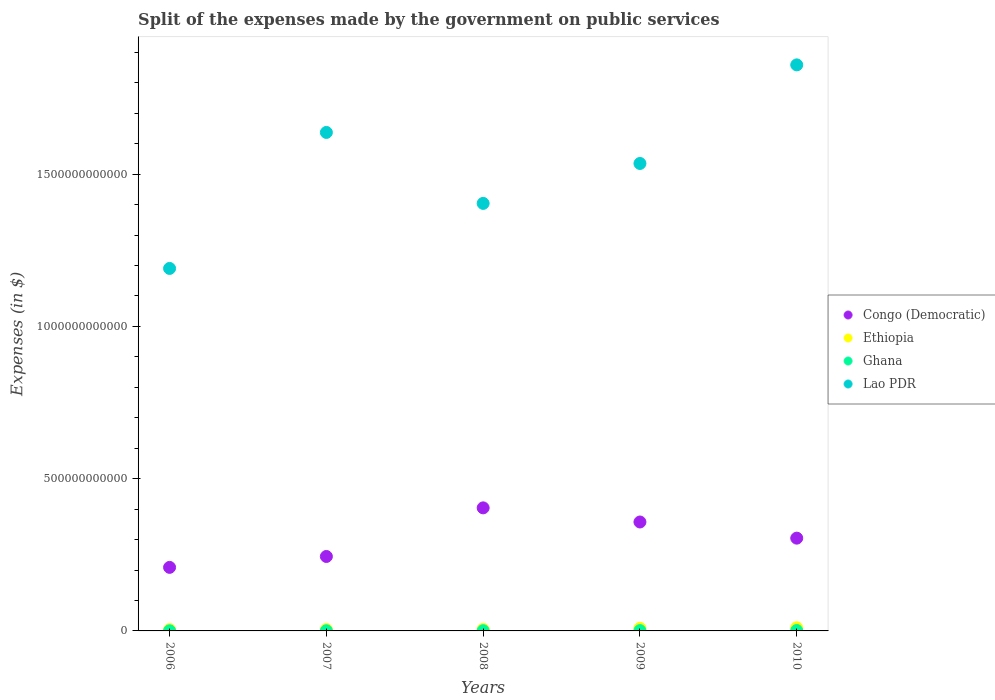Is the number of dotlines equal to the number of legend labels?
Give a very brief answer. Yes. What is the expenses made by the government on public services in Congo (Democratic) in 2007?
Your answer should be compact. 2.44e+11. Across all years, what is the maximum expenses made by the government on public services in Lao PDR?
Provide a succinct answer. 1.86e+12. Across all years, what is the minimum expenses made by the government on public services in Congo (Democratic)?
Offer a very short reply. 2.09e+11. In which year was the expenses made by the government on public services in Congo (Democratic) minimum?
Ensure brevity in your answer.  2006. What is the total expenses made by the government on public services in Ghana in the graph?
Offer a very short reply. 4.28e+09. What is the difference between the expenses made by the government on public services in Lao PDR in 2006 and that in 2009?
Make the answer very short. -3.45e+11. What is the difference between the expenses made by the government on public services in Ghana in 2008 and the expenses made by the government on public services in Congo (Democratic) in 2010?
Provide a succinct answer. -3.04e+11. What is the average expenses made by the government on public services in Ghana per year?
Provide a succinct answer. 8.55e+08. In the year 2008, what is the difference between the expenses made by the government on public services in Congo (Democratic) and expenses made by the government on public services in Ethiopia?
Offer a terse response. 3.99e+11. In how many years, is the expenses made by the government on public services in Lao PDR greater than 900000000000 $?
Provide a short and direct response. 5. What is the ratio of the expenses made by the government on public services in Congo (Democratic) in 2006 to that in 2008?
Provide a succinct answer. 0.52. Is the expenses made by the government on public services in Congo (Democratic) in 2006 less than that in 2007?
Your response must be concise. Yes. Is the difference between the expenses made by the government on public services in Congo (Democratic) in 2009 and 2010 greater than the difference between the expenses made by the government on public services in Ethiopia in 2009 and 2010?
Give a very brief answer. Yes. What is the difference between the highest and the second highest expenses made by the government on public services in Congo (Democratic)?
Give a very brief answer. 4.64e+1. What is the difference between the highest and the lowest expenses made by the government on public services in Congo (Democratic)?
Your answer should be very brief. 1.95e+11. Is the sum of the expenses made by the government on public services in Congo (Democratic) in 2007 and 2009 greater than the maximum expenses made by the government on public services in Ghana across all years?
Your response must be concise. Yes. Is it the case that in every year, the sum of the expenses made by the government on public services in Ethiopia and expenses made by the government on public services in Ghana  is greater than the sum of expenses made by the government on public services in Congo (Democratic) and expenses made by the government on public services in Lao PDR?
Your answer should be compact. No. Is it the case that in every year, the sum of the expenses made by the government on public services in Lao PDR and expenses made by the government on public services in Congo (Democratic)  is greater than the expenses made by the government on public services in Ethiopia?
Make the answer very short. Yes. Is the expenses made by the government on public services in Ethiopia strictly less than the expenses made by the government on public services in Lao PDR over the years?
Offer a very short reply. Yes. What is the difference between two consecutive major ticks on the Y-axis?
Give a very brief answer. 5.00e+11. Does the graph contain any zero values?
Ensure brevity in your answer.  No. How are the legend labels stacked?
Your answer should be very brief. Vertical. What is the title of the graph?
Ensure brevity in your answer.  Split of the expenses made by the government on public services. Does "Turks and Caicos Islands" appear as one of the legend labels in the graph?
Your answer should be compact. No. What is the label or title of the X-axis?
Offer a terse response. Years. What is the label or title of the Y-axis?
Your answer should be very brief. Expenses (in $). What is the Expenses (in $) in Congo (Democratic) in 2006?
Give a very brief answer. 2.09e+11. What is the Expenses (in $) of Ethiopia in 2006?
Offer a very short reply. 4.31e+09. What is the Expenses (in $) of Ghana in 2006?
Provide a short and direct response. 4.57e+08. What is the Expenses (in $) in Lao PDR in 2006?
Ensure brevity in your answer.  1.19e+12. What is the Expenses (in $) in Congo (Democratic) in 2007?
Your response must be concise. 2.44e+11. What is the Expenses (in $) in Ethiopia in 2007?
Your response must be concise. 4.71e+09. What is the Expenses (in $) in Ghana in 2007?
Offer a terse response. 6.16e+08. What is the Expenses (in $) in Lao PDR in 2007?
Provide a short and direct response. 1.64e+12. What is the Expenses (in $) in Congo (Democratic) in 2008?
Provide a short and direct response. 4.04e+11. What is the Expenses (in $) of Ethiopia in 2008?
Your answer should be very brief. 5.04e+09. What is the Expenses (in $) of Ghana in 2008?
Offer a very short reply. 7.44e+08. What is the Expenses (in $) in Lao PDR in 2008?
Your response must be concise. 1.40e+12. What is the Expenses (in $) of Congo (Democratic) in 2009?
Your answer should be very brief. 3.58e+11. What is the Expenses (in $) of Ethiopia in 2009?
Offer a very short reply. 8.59e+09. What is the Expenses (in $) of Ghana in 2009?
Provide a succinct answer. 1.09e+09. What is the Expenses (in $) of Lao PDR in 2009?
Your answer should be compact. 1.54e+12. What is the Expenses (in $) in Congo (Democratic) in 2010?
Make the answer very short. 3.05e+11. What is the Expenses (in $) in Ethiopia in 2010?
Your answer should be very brief. 1.04e+1. What is the Expenses (in $) of Ghana in 2010?
Ensure brevity in your answer.  1.37e+09. What is the Expenses (in $) in Lao PDR in 2010?
Offer a very short reply. 1.86e+12. Across all years, what is the maximum Expenses (in $) of Congo (Democratic)?
Provide a short and direct response. 4.04e+11. Across all years, what is the maximum Expenses (in $) in Ethiopia?
Ensure brevity in your answer.  1.04e+1. Across all years, what is the maximum Expenses (in $) of Ghana?
Ensure brevity in your answer.  1.37e+09. Across all years, what is the maximum Expenses (in $) in Lao PDR?
Keep it short and to the point. 1.86e+12. Across all years, what is the minimum Expenses (in $) in Congo (Democratic)?
Offer a terse response. 2.09e+11. Across all years, what is the minimum Expenses (in $) in Ethiopia?
Your response must be concise. 4.31e+09. Across all years, what is the minimum Expenses (in $) in Ghana?
Provide a short and direct response. 4.57e+08. Across all years, what is the minimum Expenses (in $) in Lao PDR?
Give a very brief answer. 1.19e+12. What is the total Expenses (in $) of Congo (Democratic) in the graph?
Ensure brevity in your answer.  1.52e+12. What is the total Expenses (in $) in Ethiopia in the graph?
Provide a succinct answer. 3.30e+1. What is the total Expenses (in $) of Ghana in the graph?
Provide a succinct answer. 4.28e+09. What is the total Expenses (in $) in Lao PDR in the graph?
Your answer should be very brief. 7.63e+12. What is the difference between the Expenses (in $) in Congo (Democratic) in 2006 and that in 2007?
Keep it short and to the point. -3.58e+1. What is the difference between the Expenses (in $) in Ethiopia in 2006 and that in 2007?
Your answer should be compact. -3.93e+08. What is the difference between the Expenses (in $) of Ghana in 2006 and that in 2007?
Provide a succinct answer. -1.59e+08. What is the difference between the Expenses (in $) of Lao PDR in 2006 and that in 2007?
Make the answer very short. -4.47e+11. What is the difference between the Expenses (in $) in Congo (Democratic) in 2006 and that in 2008?
Your answer should be very brief. -1.95e+11. What is the difference between the Expenses (in $) of Ethiopia in 2006 and that in 2008?
Make the answer very short. -7.27e+08. What is the difference between the Expenses (in $) of Ghana in 2006 and that in 2008?
Provide a short and direct response. -2.87e+08. What is the difference between the Expenses (in $) of Lao PDR in 2006 and that in 2008?
Offer a terse response. -2.14e+11. What is the difference between the Expenses (in $) of Congo (Democratic) in 2006 and that in 2009?
Keep it short and to the point. -1.49e+11. What is the difference between the Expenses (in $) of Ethiopia in 2006 and that in 2009?
Your response must be concise. -4.27e+09. What is the difference between the Expenses (in $) of Ghana in 2006 and that in 2009?
Make the answer very short. -6.30e+08. What is the difference between the Expenses (in $) of Lao PDR in 2006 and that in 2009?
Ensure brevity in your answer.  -3.45e+11. What is the difference between the Expenses (in $) in Congo (Democratic) in 2006 and that in 2010?
Offer a very short reply. -9.60e+1. What is the difference between the Expenses (in $) of Ethiopia in 2006 and that in 2010?
Provide a succinct answer. -6.05e+09. What is the difference between the Expenses (in $) of Ghana in 2006 and that in 2010?
Make the answer very short. -9.15e+08. What is the difference between the Expenses (in $) in Lao PDR in 2006 and that in 2010?
Your answer should be compact. -6.68e+11. What is the difference between the Expenses (in $) in Congo (Democratic) in 2007 and that in 2008?
Offer a terse response. -1.60e+11. What is the difference between the Expenses (in $) of Ethiopia in 2007 and that in 2008?
Your answer should be very brief. -3.34e+08. What is the difference between the Expenses (in $) of Ghana in 2007 and that in 2008?
Provide a succinct answer. -1.28e+08. What is the difference between the Expenses (in $) of Lao PDR in 2007 and that in 2008?
Provide a short and direct response. 2.33e+11. What is the difference between the Expenses (in $) in Congo (Democratic) in 2007 and that in 2009?
Offer a terse response. -1.13e+11. What is the difference between the Expenses (in $) in Ethiopia in 2007 and that in 2009?
Provide a succinct answer. -3.88e+09. What is the difference between the Expenses (in $) in Ghana in 2007 and that in 2009?
Keep it short and to the point. -4.72e+08. What is the difference between the Expenses (in $) in Lao PDR in 2007 and that in 2009?
Keep it short and to the point. 1.02e+11. What is the difference between the Expenses (in $) of Congo (Democratic) in 2007 and that in 2010?
Your answer should be compact. -6.02e+1. What is the difference between the Expenses (in $) of Ethiopia in 2007 and that in 2010?
Your response must be concise. -5.66e+09. What is the difference between the Expenses (in $) of Ghana in 2007 and that in 2010?
Make the answer very short. -7.56e+08. What is the difference between the Expenses (in $) of Lao PDR in 2007 and that in 2010?
Your answer should be very brief. -2.22e+11. What is the difference between the Expenses (in $) in Congo (Democratic) in 2008 and that in 2009?
Keep it short and to the point. 4.64e+1. What is the difference between the Expenses (in $) in Ethiopia in 2008 and that in 2009?
Keep it short and to the point. -3.55e+09. What is the difference between the Expenses (in $) in Ghana in 2008 and that in 2009?
Provide a succinct answer. -3.44e+08. What is the difference between the Expenses (in $) of Lao PDR in 2008 and that in 2009?
Provide a succinct answer. -1.31e+11. What is the difference between the Expenses (in $) of Congo (Democratic) in 2008 and that in 2010?
Make the answer very short. 9.95e+1. What is the difference between the Expenses (in $) of Ethiopia in 2008 and that in 2010?
Your answer should be very brief. -5.32e+09. What is the difference between the Expenses (in $) of Ghana in 2008 and that in 2010?
Provide a succinct answer. -6.28e+08. What is the difference between the Expenses (in $) in Lao PDR in 2008 and that in 2010?
Make the answer very short. -4.55e+11. What is the difference between the Expenses (in $) of Congo (Democratic) in 2009 and that in 2010?
Make the answer very short. 5.30e+1. What is the difference between the Expenses (in $) of Ethiopia in 2009 and that in 2010?
Offer a terse response. -1.78e+09. What is the difference between the Expenses (in $) of Ghana in 2009 and that in 2010?
Offer a terse response. -2.84e+08. What is the difference between the Expenses (in $) in Lao PDR in 2009 and that in 2010?
Your answer should be compact. -3.24e+11. What is the difference between the Expenses (in $) in Congo (Democratic) in 2006 and the Expenses (in $) in Ethiopia in 2007?
Keep it short and to the point. 2.04e+11. What is the difference between the Expenses (in $) in Congo (Democratic) in 2006 and the Expenses (in $) in Ghana in 2007?
Your answer should be compact. 2.08e+11. What is the difference between the Expenses (in $) of Congo (Democratic) in 2006 and the Expenses (in $) of Lao PDR in 2007?
Offer a terse response. -1.43e+12. What is the difference between the Expenses (in $) of Ethiopia in 2006 and the Expenses (in $) of Ghana in 2007?
Your answer should be very brief. 3.70e+09. What is the difference between the Expenses (in $) of Ethiopia in 2006 and the Expenses (in $) of Lao PDR in 2007?
Ensure brevity in your answer.  -1.63e+12. What is the difference between the Expenses (in $) in Ghana in 2006 and the Expenses (in $) in Lao PDR in 2007?
Keep it short and to the point. -1.64e+12. What is the difference between the Expenses (in $) of Congo (Democratic) in 2006 and the Expenses (in $) of Ethiopia in 2008?
Your answer should be compact. 2.04e+11. What is the difference between the Expenses (in $) of Congo (Democratic) in 2006 and the Expenses (in $) of Ghana in 2008?
Keep it short and to the point. 2.08e+11. What is the difference between the Expenses (in $) in Congo (Democratic) in 2006 and the Expenses (in $) in Lao PDR in 2008?
Your response must be concise. -1.20e+12. What is the difference between the Expenses (in $) in Ethiopia in 2006 and the Expenses (in $) in Ghana in 2008?
Keep it short and to the point. 3.57e+09. What is the difference between the Expenses (in $) of Ethiopia in 2006 and the Expenses (in $) of Lao PDR in 2008?
Your answer should be compact. -1.40e+12. What is the difference between the Expenses (in $) in Ghana in 2006 and the Expenses (in $) in Lao PDR in 2008?
Provide a short and direct response. -1.40e+12. What is the difference between the Expenses (in $) of Congo (Democratic) in 2006 and the Expenses (in $) of Ethiopia in 2009?
Your answer should be very brief. 2.00e+11. What is the difference between the Expenses (in $) in Congo (Democratic) in 2006 and the Expenses (in $) in Ghana in 2009?
Ensure brevity in your answer.  2.08e+11. What is the difference between the Expenses (in $) of Congo (Democratic) in 2006 and the Expenses (in $) of Lao PDR in 2009?
Your response must be concise. -1.33e+12. What is the difference between the Expenses (in $) in Ethiopia in 2006 and the Expenses (in $) in Ghana in 2009?
Offer a terse response. 3.23e+09. What is the difference between the Expenses (in $) of Ethiopia in 2006 and the Expenses (in $) of Lao PDR in 2009?
Make the answer very short. -1.53e+12. What is the difference between the Expenses (in $) of Ghana in 2006 and the Expenses (in $) of Lao PDR in 2009?
Your answer should be compact. -1.53e+12. What is the difference between the Expenses (in $) of Congo (Democratic) in 2006 and the Expenses (in $) of Ethiopia in 2010?
Keep it short and to the point. 1.98e+11. What is the difference between the Expenses (in $) in Congo (Democratic) in 2006 and the Expenses (in $) in Ghana in 2010?
Your answer should be compact. 2.07e+11. What is the difference between the Expenses (in $) of Congo (Democratic) in 2006 and the Expenses (in $) of Lao PDR in 2010?
Provide a short and direct response. -1.65e+12. What is the difference between the Expenses (in $) in Ethiopia in 2006 and the Expenses (in $) in Ghana in 2010?
Provide a succinct answer. 2.94e+09. What is the difference between the Expenses (in $) in Ethiopia in 2006 and the Expenses (in $) in Lao PDR in 2010?
Keep it short and to the point. -1.85e+12. What is the difference between the Expenses (in $) in Ghana in 2006 and the Expenses (in $) in Lao PDR in 2010?
Make the answer very short. -1.86e+12. What is the difference between the Expenses (in $) in Congo (Democratic) in 2007 and the Expenses (in $) in Ethiopia in 2008?
Make the answer very short. 2.39e+11. What is the difference between the Expenses (in $) in Congo (Democratic) in 2007 and the Expenses (in $) in Ghana in 2008?
Your response must be concise. 2.44e+11. What is the difference between the Expenses (in $) in Congo (Democratic) in 2007 and the Expenses (in $) in Lao PDR in 2008?
Your answer should be very brief. -1.16e+12. What is the difference between the Expenses (in $) of Ethiopia in 2007 and the Expenses (in $) of Ghana in 2008?
Provide a succinct answer. 3.96e+09. What is the difference between the Expenses (in $) in Ethiopia in 2007 and the Expenses (in $) in Lao PDR in 2008?
Give a very brief answer. -1.40e+12. What is the difference between the Expenses (in $) in Ghana in 2007 and the Expenses (in $) in Lao PDR in 2008?
Your response must be concise. -1.40e+12. What is the difference between the Expenses (in $) in Congo (Democratic) in 2007 and the Expenses (in $) in Ethiopia in 2009?
Ensure brevity in your answer.  2.36e+11. What is the difference between the Expenses (in $) in Congo (Democratic) in 2007 and the Expenses (in $) in Ghana in 2009?
Make the answer very short. 2.43e+11. What is the difference between the Expenses (in $) of Congo (Democratic) in 2007 and the Expenses (in $) of Lao PDR in 2009?
Your answer should be very brief. -1.29e+12. What is the difference between the Expenses (in $) of Ethiopia in 2007 and the Expenses (in $) of Ghana in 2009?
Provide a succinct answer. 3.62e+09. What is the difference between the Expenses (in $) of Ethiopia in 2007 and the Expenses (in $) of Lao PDR in 2009?
Provide a succinct answer. -1.53e+12. What is the difference between the Expenses (in $) of Ghana in 2007 and the Expenses (in $) of Lao PDR in 2009?
Your answer should be compact. -1.53e+12. What is the difference between the Expenses (in $) in Congo (Democratic) in 2007 and the Expenses (in $) in Ethiopia in 2010?
Your response must be concise. 2.34e+11. What is the difference between the Expenses (in $) in Congo (Democratic) in 2007 and the Expenses (in $) in Ghana in 2010?
Offer a very short reply. 2.43e+11. What is the difference between the Expenses (in $) of Congo (Democratic) in 2007 and the Expenses (in $) of Lao PDR in 2010?
Your answer should be compact. -1.61e+12. What is the difference between the Expenses (in $) of Ethiopia in 2007 and the Expenses (in $) of Ghana in 2010?
Make the answer very short. 3.33e+09. What is the difference between the Expenses (in $) in Ethiopia in 2007 and the Expenses (in $) in Lao PDR in 2010?
Offer a terse response. -1.85e+12. What is the difference between the Expenses (in $) in Ghana in 2007 and the Expenses (in $) in Lao PDR in 2010?
Make the answer very short. -1.86e+12. What is the difference between the Expenses (in $) in Congo (Democratic) in 2008 and the Expenses (in $) in Ethiopia in 2009?
Give a very brief answer. 3.96e+11. What is the difference between the Expenses (in $) in Congo (Democratic) in 2008 and the Expenses (in $) in Ghana in 2009?
Ensure brevity in your answer.  4.03e+11. What is the difference between the Expenses (in $) of Congo (Democratic) in 2008 and the Expenses (in $) of Lao PDR in 2009?
Provide a succinct answer. -1.13e+12. What is the difference between the Expenses (in $) of Ethiopia in 2008 and the Expenses (in $) of Ghana in 2009?
Keep it short and to the point. 3.95e+09. What is the difference between the Expenses (in $) of Ethiopia in 2008 and the Expenses (in $) of Lao PDR in 2009?
Ensure brevity in your answer.  -1.53e+12. What is the difference between the Expenses (in $) in Ghana in 2008 and the Expenses (in $) in Lao PDR in 2009?
Your answer should be compact. -1.53e+12. What is the difference between the Expenses (in $) of Congo (Democratic) in 2008 and the Expenses (in $) of Ethiopia in 2010?
Provide a succinct answer. 3.94e+11. What is the difference between the Expenses (in $) in Congo (Democratic) in 2008 and the Expenses (in $) in Ghana in 2010?
Your answer should be compact. 4.03e+11. What is the difference between the Expenses (in $) of Congo (Democratic) in 2008 and the Expenses (in $) of Lao PDR in 2010?
Provide a succinct answer. -1.45e+12. What is the difference between the Expenses (in $) of Ethiopia in 2008 and the Expenses (in $) of Ghana in 2010?
Your answer should be very brief. 3.67e+09. What is the difference between the Expenses (in $) in Ethiopia in 2008 and the Expenses (in $) in Lao PDR in 2010?
Provide a succinct answer. -1.85e+12. What is the difference between the Expenses (in $) of Ghana in 2008 and the Expenses (in $) of Lao PDR in 2010?
Make the answer very short. -1.86e+12. What is the difference between the Expenses (in $) in Congo (Democratic) in 2009 and the Expenses (in $) in Ethiopia in 2010?
Provide a succinct answer. 3.47e+11. What is the difference between the Expenses (in $) in Congo (Democratic) in 2009 and the Expenses (in $) in Ghana in 2010?
Offer a terse response. 3.56e+11. What is the difference between the Expenses (in $) of Congo (Democratic) in 2009 and the Expenses (in $) of Lao PDR in 2010?
Your answer should be very brief. -1.50e+12. What is the difference between the Expenses (in $) in Ethiopia in 2009 and the Expenses (in $) in Ghana in 2010?
Make the answer very short. 7.22e+09. What is the difference between the Expenses (in $) of Ethiopia in 2009 and the Expenses (in $) of Lao PDR in 2010?
Your answer should be compact. -1.85e+12. What is the difference between the Expenses (in $) of Ghana in 2009 and the Expenses (in $) of Lao PDR in 2010?
Your answer should be very brief. -1.86e+12. What is the average Expenses (in $) of Congo (Democratic) per year?
Your answer should be very brief. 3.04e+11. What is the average Expenses (in $) in Ethiopia per year?
Provide a short and direct response. 6.60e+09. What is the average Expenses (in $) of Ghana per year?
Your answer should be very brief. 8.55e+08. What is the average Expenses (in $) of Lao PDR per year?
Give a very brief answer. 1.53e+12. In the year 2006, what is the difference between the Expenses (in $) of Congo (Democratic) and Expenses (in $) of Ethiopia?
Keep it short and to the point. 2.04e+11. In the year 2006, what is the difference between the Expenses (in $) in Congo (Democratic) and Expenses (in $) in Ghana?
Your answer should be very brief. 2.08e+11. In the year 2006, what is the difference between the Expenses (in $) in Congo (Democratic) and Expenses (in $) in Lao PDR?
Ensure brevity in your answer.  -9.82e+11. In the year 2006, what is the difference between the Expenses (in $) of Ethiopia and Expenses (in $) of Ghana?
Your answer should be compact. 3.86e+09. In the year 2006, what is the difference between the Expenses (in $) of Ethiopia and Expenses (in $) of Lao PDR?
Provide a short and direct response. -1.19e+12. In the year 2006, what is the difference between the Expenses (in $) of Ghana and Expenses (in $) of Lao PDR?
Offer a terse response. -1.19e+12. In the year 2007, what is the difference between the Expenses (in $) of Congo (Democratic) and Expenses (in $) of Ethiopia?
Your answer should be very brief. 2.40e+11. In the year 2007, what is the difference between the Expenses (in $) in Congo (Democratic) and Expenses (in $) in Ghana?
Your answer should be very brief. 2.44e+11. In the year 2007, what is the difference between the Expenses (in $) in Congo (Democratic) and Expenses (in $) in Lao PDR?
Your response must be concise. -1.39e+12. In the year 2007, what is the difference between the Expenses (in $) of Ethiopia and Expenses (in $) of Ghana?
Ensure brevity in your answer.  4.09e+09. In the year 2007, what is the difference between the Expenses (in $) in Ethiopia and Expenses (in $) in Lao PDR?
Your answer should be very brief. -1.63e+12. In the year 2007, what is the difference between the Expenses (in $) of Ghana and Expenses (in $) of Lao PDR?
Offer a very short reply. -1.64e+12. In the year 2008, what is the difference between the Expenses (in $) of Congo (Democratic) and Expenses (in $) of Ethiopia?
Give a very brief answer. 3.99e+11. In the year 2008, what is the difference between the Expenses (in $) in Congo (Democratic) and Expenses (in $) in Ghana?
Your response must be concise. 4.03e+11. In the year 2008, what is the difference between the Expenses (in $) in Congo (Democratic) and Expenses (in $) in Lao PDR?
Your answer should be very brief. -1.00e+12. In the year 2008, what is the difference between the Expenses (in $) in Ethiopia and Expenses (in $) in Ghana?
Your answer should be very brief. 4.30e+09. In the year 2008, what is the difference between the Expenses (in $) in Ethiopia and Expenses (in $) in Lao PDR?
Provide a short and direct response. -1.40e+12. In the year 2008, what is the difference between the Expenses (in $) in Ghana and Expenses (in $) in Lao PDR?
Your answer should be compact. -1.40e+12. In the year 2009, what is the difference between the Expenses (in $) in Congo (Democratic) and Expenses (in $) in Ethiopia?
Make the answer very short. 3.49e+11. In the year 2009, what is the difference between the Expenses (in $) of Congo (Democratic) and Expenses (in $) of Ghana?
Ensure brevity in your answer.  3.57e+11. In the year 2009, what is the difference between the Expenses (in $) of Congo (Democratic) and Expenses (in $) of Lao PDR?
Offer a very short reply. -1.18e+12. In the year 2009, what is the difference between the Expenses (in $) in Ethiopia and Expenses (in $) in Ghana?
Your answer should be compact. 7.50e+09. In the year 2009, what is the difference between the Expenses (in $) in Ethiopia and Expenses (in $) in Lao PDR?
Keep it short and to the point. -1.53e+12. In the year 2009, what is the difference between the Expenses (in $) in Ghana and Expenses (in $) in Lao PDR?
Your response must be concise. -1.53e+12. In the year 2010, what is the difference between the Expenses (in $) in Congo (Democratic) and Expenses (in $) in Ethiopia?
Your response must be concise. 2.94e+11. In the year 2010, what is the difference between the Expenses (in $) in Congo (Democratic) and Expenses (in $) in Ghana?
Provide a short and direct response. 3.03e+11. In the year 2010, what is the difference between the Expenses (in $) of Congo (Democratic) and Expenses (in $) of Lao PDR?
Your answer should be very brief. -1.55e+12. In the year 2010, what is the difference between the Expenses (in $) in Ethiopia and Expenses (in $) in Ghana?
Offer a very short reply. 8.99e+09. In the year 2010, what is the difference between the Expenses (in $) of Ethiopia and Expenses (in $) of Lao PDR?
Offer a terse response. -1.85e+12. In the year 2010, what is the difference between the Expenses (in $) in Ghana and Expenses (in $) in Lao PDR?
Ensure brevity in your answer.  -1.86e+12. What is the ratio of the Expenses (in $) of Congo (Democratic) in 2006 to that in 2007?
Provide a short and direct response. 0.85. What is the ratio of the Expenses (in $) of Ethiopia in 2006 to that in 2007?
Offer a terse response. 0.92. What is the ratio of the Expenses (in $) in Ghana in 2006 to that in 2007?
Offer a very short reply. 0.74. What is the ratio of the Expenses (in $) in Lao PDR in 2006 to that in 2007?
Keep it short and to the point. 0.73. What is the ratio of the Expenses (in $) of Congo (Democratic) in 2006 to that in 2008?
Offer a terse response. 0.52. What is the ratio of the Expenses (in $) in Ethiopia in 2006 to that in 2008?
Ensure brevity in your answer.  0.86. What is the ratio of the Expenses (in $) of Ghana in 2006 to that in 2008?
Your answer should be compact. 0.61. What is the ratio of the Expenses (in $) in Lao PDR in 2006 to that in 2008?
Provide a succinct answer. 0.85. What is the ratio of the Expenses (in $) in Congo (Democratic) in 2006 to that in 2009?
Your answer should be very brief. 0.58. What is the ratio of the Expenses (in $) of Ethiopia in 2006 to that in 2009?
Ensure brevity in your answer.  0.5. What is the ratio of the Expenses (in $) of Ghana in 2006 to that in 2009?
Make the answer very short. 0.42. What is the ratio of the Expenses (in $) of Lao PDR in 2006 to that in 2009?
Provide a succinct answer. 0.78. What is the ratio of the Expenses (in $) in Congo (Democratic) in 2006 to that in 2010?
Offer a very short reply. 0.69. What is the ratio of the Expenses (in $) in Ethiopia in 2006 to that in 2010?
Provide a succinct answer. 0.42. What is the ratio of the Expenses (in $) in Lao PDR in 2006 to that in 2010?
Provide a short and direct response. 0.64. What is the ratio of the Expenses (in $) of Congo (Democratic) in 2007 to that in 2008?
Ensure brevity in your answer.  0.6. What is the ratio of the Expenses (in $) of Ethiopia in 2007 to that in 2008?
Your response must be concise. 0.93. What is the ratio of the Expenses (in $) in Ghana in 2007 to that in 2008?
Ensure brevity in your answer.  0.83. What is the ratio of the Expenses (in $) in Lao PDR in 2007 to that in 2008?
Make the answer very short. 1.17. What is the ratio of the Expenses (in $) of Congo (Democratic) in 2007 to that in 2009?
Make the answer very short. 0.68. What is the ratio of the Expenses (in $) of Ethiopia in 2007 to that in 2009?
Provide a short and direct response. 0.55. What is the ratio of the Expenses (in $) of Ghana in 2007 to that in 2009?
Make the answer very short. 0.57. What is the ratio of the Expenses (in $) of Lao PDR in 2007 to that in 2009?
Provide a succinct answer. 1.07. What is the ratio of the Expenses (in $) in Congo (Democratic) in 2007 to that in 2010?
Your response must be concise. 0.8. What is the ratio of the Expenses (in $) of Ethiopia in 2007 to that in 2010?
Your answer should be compact. 0.45. What is the ratio of the Expenses (in $) of Ghana in 2007 to that in 2010?
Your answer should be compact. 0.45. What is the ratio of the Expenses (in $) of Lao PDR in 2007 to that in 2010?
Your answer should be compact. 0.88. What is the ratio of the Expenses (in $) in Congo (Democratic) in 2008 to that in 2009?
Provide a short and direct response. 1.13. What is the ratio of the Expenses (in $) in Ethiopia in 2008 to that in 2009?
Your response must be concise. 0.59. What is the ratio of the Expenses (in $) in Ghana in 2008 to that in 2009?
Your answer should be compact. 0.68. What is the ratio of the Expenses (in $) of Lao PDR in 2008 to that in 2009?
Keep it short and to the point. 0.91. What is the ratio of the Expenses (in $) in Congo (Democratic) in 2008 to that in 2010?
Provide a succinct answer. 1.33. What is the ratio of the Expenses (in $) in Ethiopia in 2008 to that in 2010?
Your answer should be very brief. 0.49. What is the ratio of the Expenses (in $) of Ghana in 2008 to that in 2010?
Provide a short and direct response. 0.54. What is the ratio of the Expenses (in $) in Lao PDR in 2008 to that in 2010?
Your answer should be very brief. 0.76. What is the ratio of the Expenses (in $) of Congo (Democratic) in 2009 to that in 2010?
Your response must be concise. 1.17. What is the ratio of the Expenses (in $) in Ethiopia in 2009 to that in 2010?
Offer a terse response. 0.83. What is the ratio of the Expenses (in $) in Ghana in 2009 to that in 2010?
Your answer should be compact. 0.79. What is the ratio of the Expenses (in $) in Lao PDR in 2009 to that in 2010?
Your answer should be compact. 0.83. What is the difference between the highest and the second highest Expenses (in $) of Congo (Democratic)?
Make the answer very short. 4.64e+1. What is the difference between the highest and the second highest Expenses (in $) of Ethiopia?
Your answer should be compact. 1.78e+09. What is the difference between the highest and the second highest Expenses (in $) in Ghana?
Provide a succinct answer. 2.84e+08. What is the difference between the highest and the second highest Expenses (in $) in Lao PDR?
Your response must be concise. 2.22e+11. What is the difference between the highest and the lowest Expenses (in $) of Congo (Democratic)?
Give a very brief answer. 1.95e+11. What is the difference between the highest and the lowest Expenses (in $) of Ethiopia?
Keep it short and to the point. 6.05e+09. What is the difference between the highest and the lowest Expenses (in $) of Ghana?
Keep it short and to the point. 9.15e+08. What is the difference between the highest and the lowest Expenses (in $) of Lao PDR?
Offer a very short reply. 6.68e+11. 